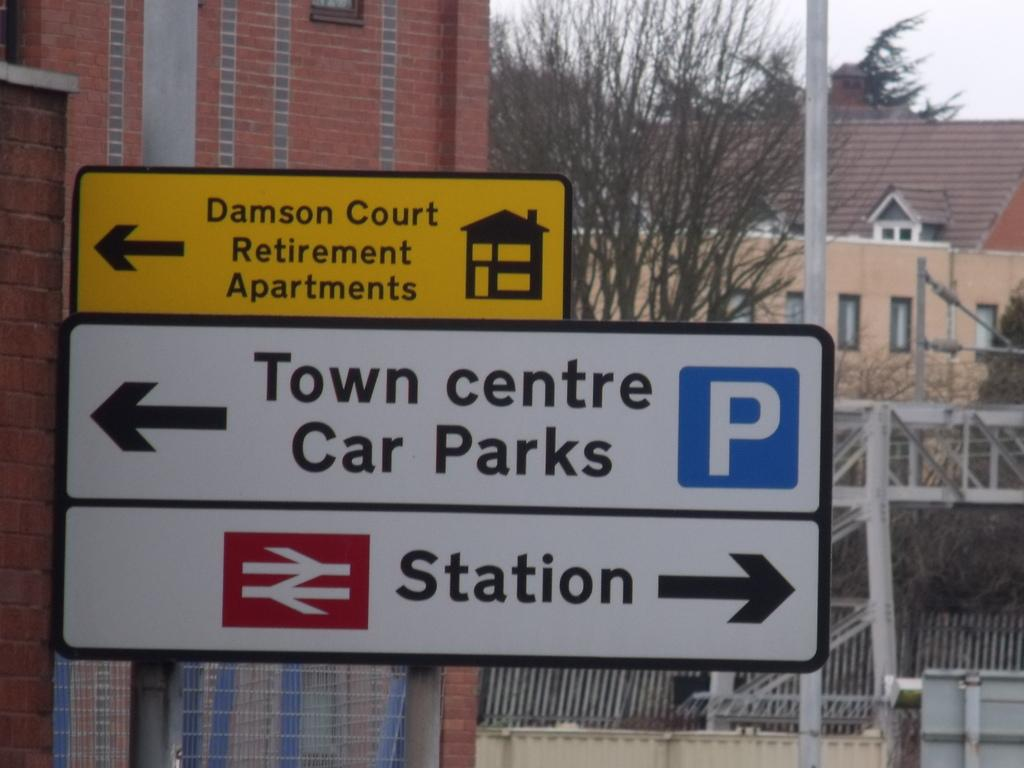<image>
Relay a brief, clear account of the picture shown. The street sign for Town Center Car Parks and the Station is shown in closeup with a background of buildings. 